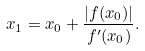<formula> <loc_0><loc_0><loc_500><loc_500>x _ { 1 } = x _ { 0 } + \frac { | f ( x _ { 0 } ) | } { f ^ { \prime } ( x _ { 0 } ) } .</formula> 